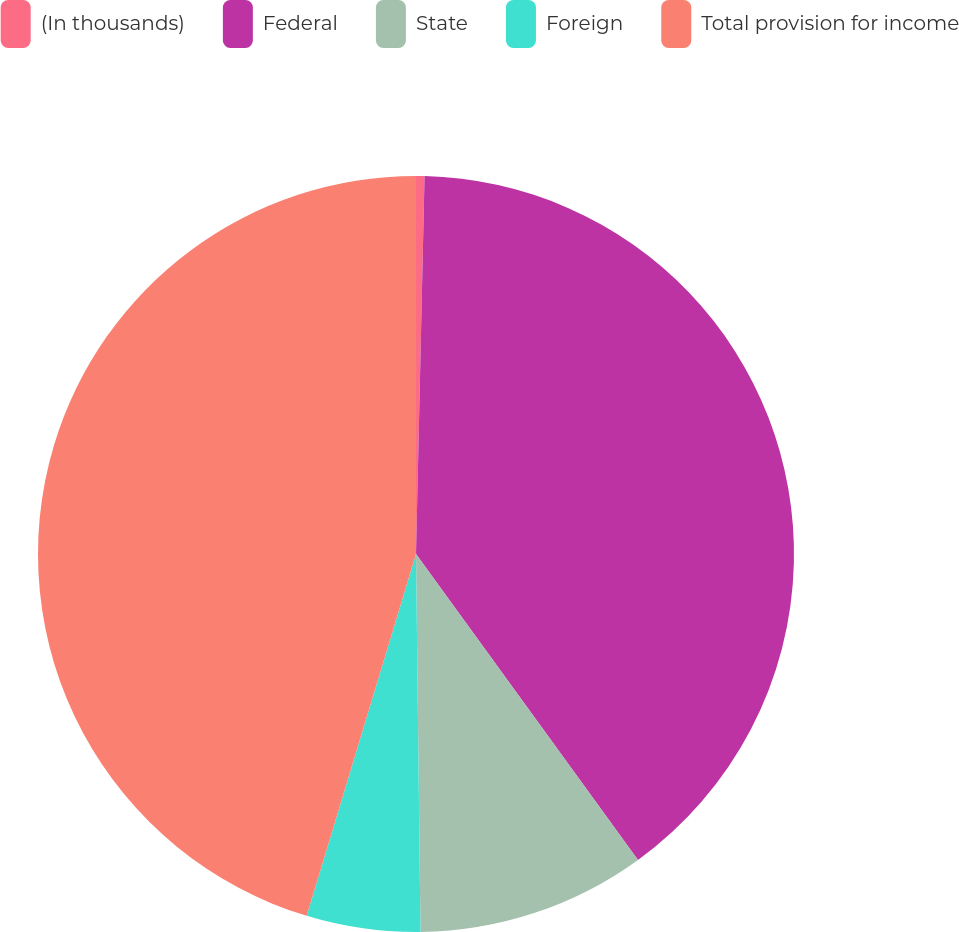<chart> <loc_0><loc_0><loc_500><loc_500><pie_chart><fcel>(In thousands)<fcel>Federal<fcel>State<fcel>Foreign<fcel>Total provision for income<nl><fcel>0.36%<fcel>39.65%<fcel>9.8%<fcel>4.86%<fcel>45.33%<nl></chart> 